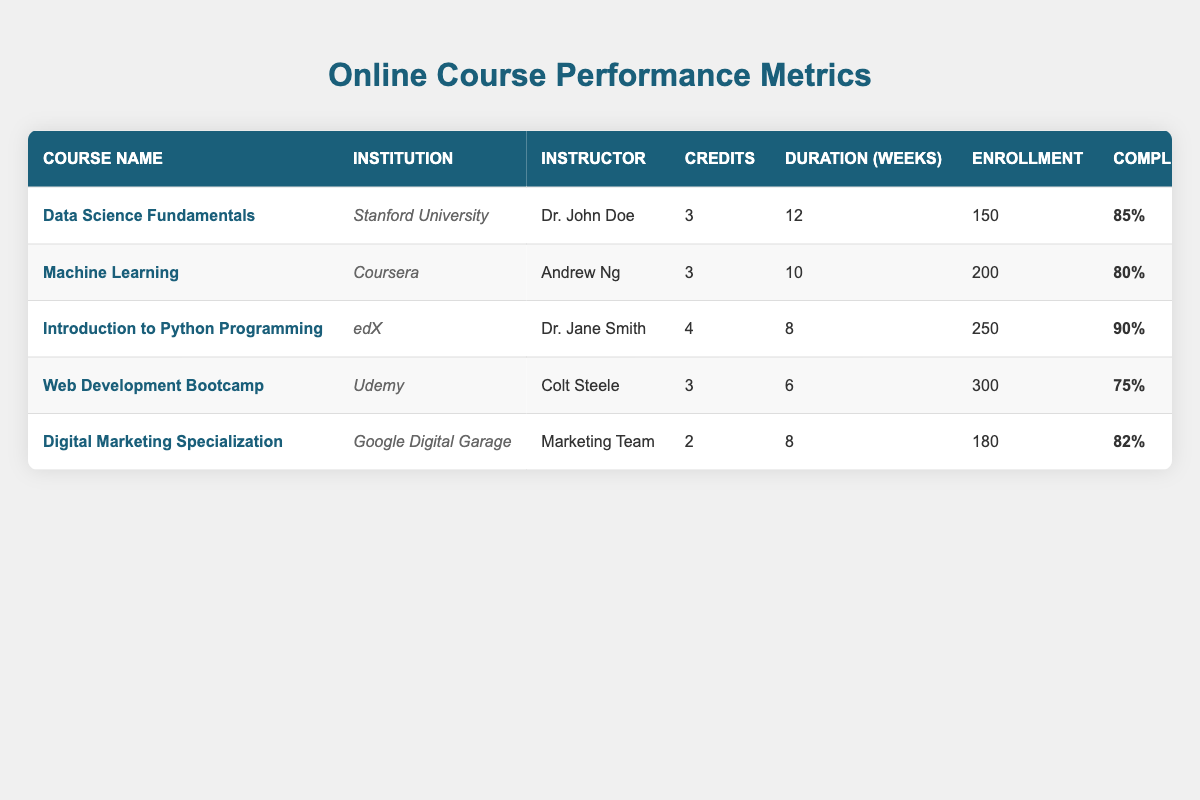What is the completion rate for the "Web Development Bootcamp" course? The completion rate is found in the respective row for the "Web Development Bootcamp" course, which shows a completion rate of 75%.
Answer: 75% How many total credits can be earned by taking all listed courses? To find the total credits, sum the credits of each course: (3 + 3 + 4 + 3 + 2) = 15 credits.
Answer: 15 Which course has the highest average grade? By comparing the average grades listed for each course, "Machine Learning" has the highest average grade of 90.
Answer: 90 Is the completion rate of "Digital Marketing Specialization" greater than 80%? The completion rate for "Digital Marketing Specialization" is 82%, which is indeed greater than 80%.
Answer: Yes What is the average enrollment across all courses? The total enrollment is (150 + 200 + 250 + 300 + 180) = 1080. To find the average, divide by the number of courses (1080/5) = 216.
Answer: 216 Which course has the least number of peer reviews completed? From the peer reviews completed column, "Digital Marketing Specialization" has the least with only 1 peer review.
Answer: 1 What is the difference in average grades between "Data Science Fundamentals" and "Web Development Bootcamp"? The average grade for "Data Science Fundamentals" is 88, and for "Web Development Bootcamp" it is 78. The difference is (88 - 78) = 10.
Answer: 10 Which course has the longest duration? Checking the duration column, "Data Science Fundamentals" has the longest duration at 12 weeks.
Answer: 12 weeks How many resources were accessed in total for all courses? The total resources accessed is calculated by summing the individual counts: (1200 + 2100 + 1500 + 800 + 950) =  7350.
Answer: 7350 Are there more assignments submitted in "Introduction to Python Programming" than in "Machine Learning"? "Introduction to Python Programming" has 6 assignments submitted, while "Machine Learning" has 8. Therefore, there are fewer assignments in "Introduction to Python Programming."
Answer: No 